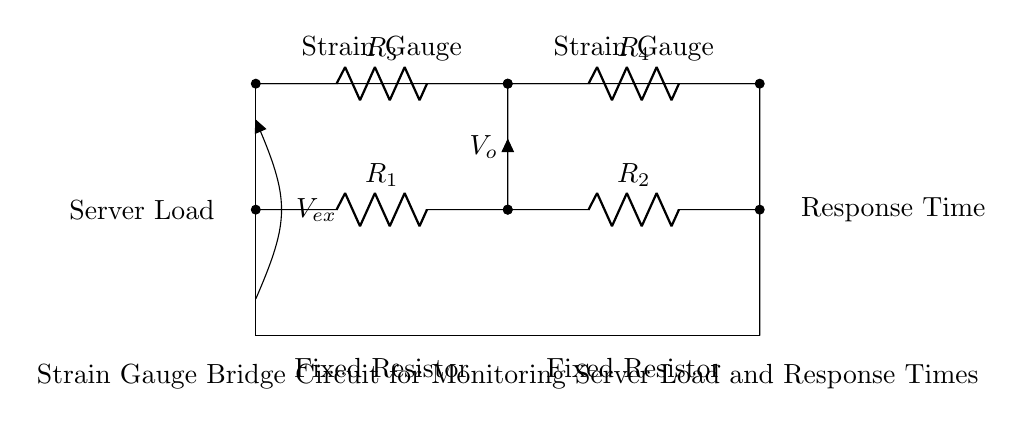What are the resistors labeled in the circuit? The circuit has four resistors labeled as R1, R2, R3, and R4. Each resistor represents a part of the strain gauge bridge circuit, which is essential for measuring changes in resistance due to server load.
Answer: R1, R2, R3, R4 What are the main components of the circuit? The main components of the circuit include four resistors and two strain gauges. The strain gauges are used for detecting strain or load, while the resistors form the bridge configuration necessary for comparing the resistances.
Answer: Resistors, Strain Gauges What is the output voltage referred to in the circuit? The output voltage in the circuit is denoted as V_o, which represents the voltage difference that results from the imbalance in the bridge circuit due to the strain gauges detecting changes in load.
Answer: V_o What type of circuit is this? This is a strain gauge bridge circuit. This specific type of circuit is designed to measure small changes in resistance which relate to physical changes such as strain on the gauges.
Answer: Strain gauge bridge How many strain gauges are present in the circuit? There are two strain gauges present in the circuit. They are positioned in parallel with the resistors and are crucial for the operation of the bridge by providing the input signals corresponding to applied strain.
Answer: Two What factor does this circuit monitor related to server operation? The circuit monitors server load. The primary function of the strain gauge bridge is to detect changes in resistance that are associated with variations in the load applied to the server, thereby providing data on its operational status.
Answer: Server Load What is the voltage supply referred to in the circuit? The voltage supply is labeled as V_ex, which is the external voltage source providing the potential for the circuit to function. It is necessary for powering the strain gauge bridge and enabling the measurement process.
Answer: V_ex 